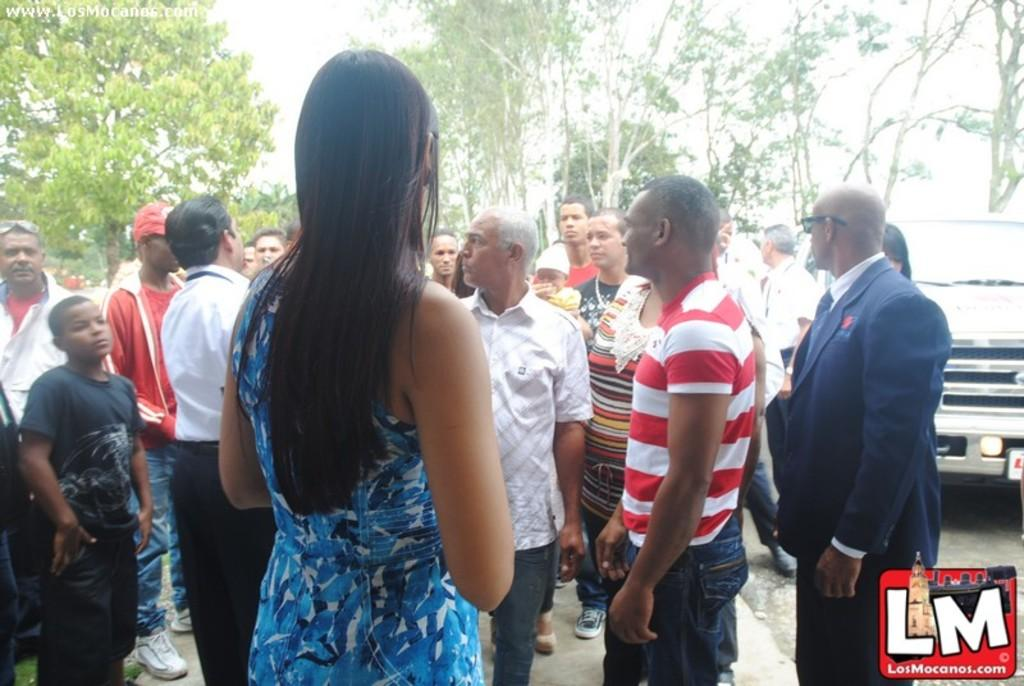What is the main focus of the image? The main focus of the image is the many people standing in the center. Can you describe any other objects or vehicles in the image? Yes, there is a car on the right side of the image. What can be seen in the background of the image? There are trees in the background of the image. How many frogs are sitting on the car in the image? There are no frogs present in the image, and therefore no frogs are sitting on the car. What class is being taught in the image? There is no indication of a class or teaching in the image. 